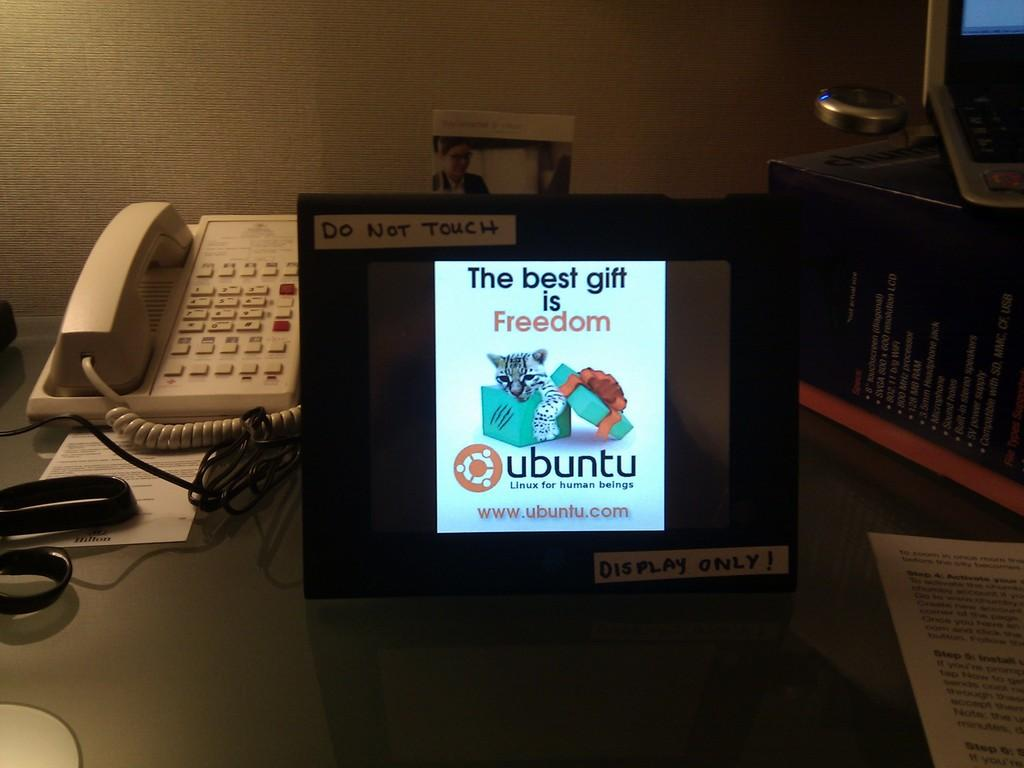What is the main object or feature in the image? There is a display in the image. What type of item can be seen on the display? There is a paper in the image. What is connected to the display? There is a cable wire in the image. What tool is present in the image? There is a scissor in the image. What communication device is visible in the image? There is a telephone in the image. What type of decoration or information source is present in the image? There is a poster in the image. What container or storage object is visible in the image? There is a box in the image. Are there any fairies visible in the image? No, there are no fairies present in the image. Who is the owner of the items in the image? The image does not provide information about the owner of the items. 